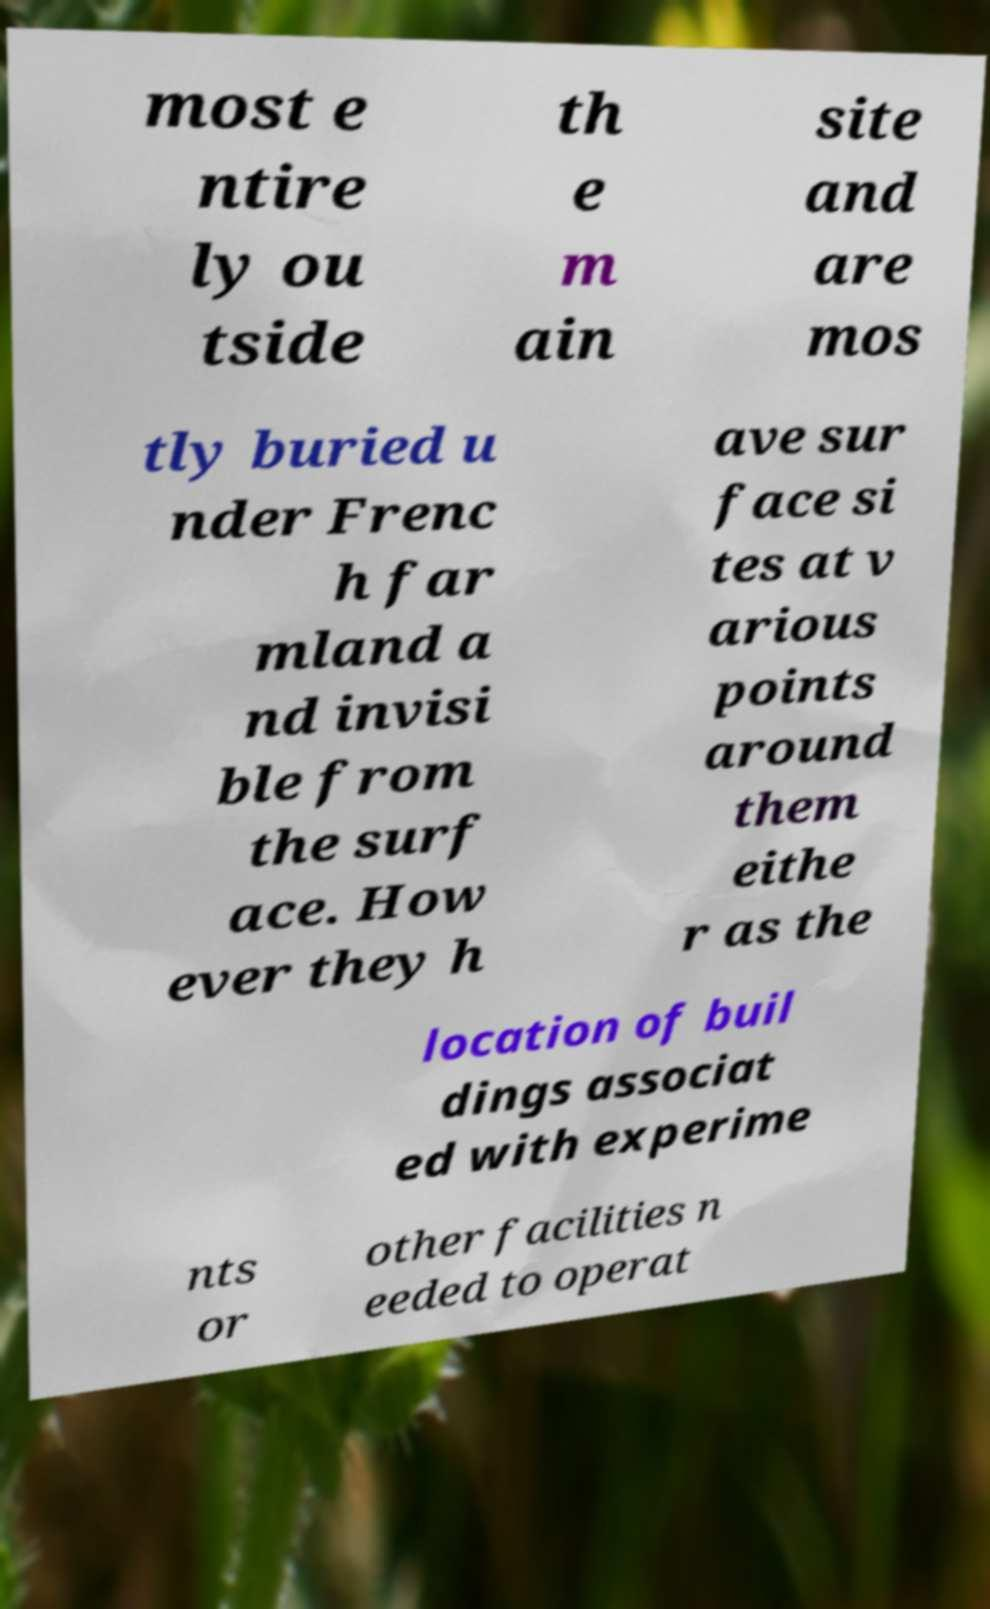I need the written content from this picture converted into text. Can you do that? most e ntire ly ou tside th e m ain site and are mos tly buried u nder Frenc h far mland a nd invisi ble from the surf ace. How ever they h ave sur face si tes at v arious points around them eithe r as the location of buil dings associat ed with experime nts or other facilities n eeded to operat 